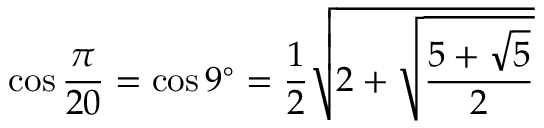<formula> <loc_0><loc_0><loc_500><loc_500>\cos { \frac { \pi } { 2 0 } } = \cos 9 ^ { \circ } = { \frac { 1 } { 2 } } { \sqrt { 2 + { \sqrt { \frac { 5 + { \sqrt { 5 } } } { 2 } } } } }</formula> 